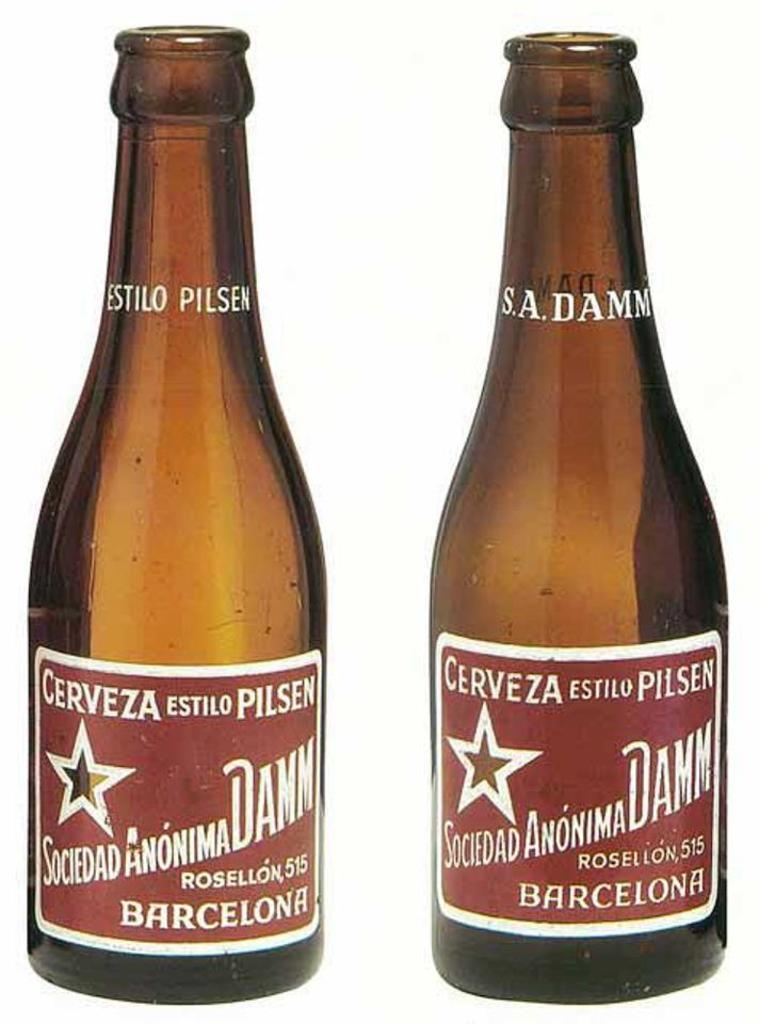Provide a one-sentence caption for the provided image. Two empty brown bottles of cerveza from Barcelona. 